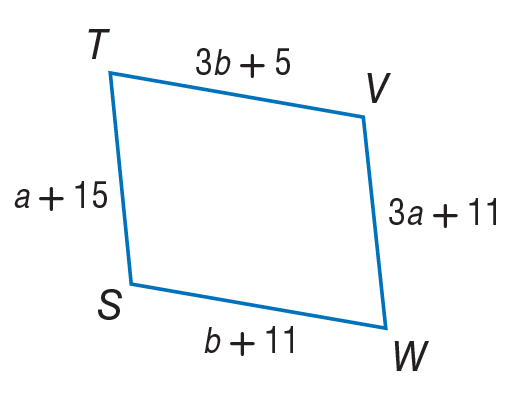Question: Use parallelogram to, find a.
Choices:
A. 1
B. 2
C. 3
D. 4
Answer with the letter. Answer: B Question: Use parallelogram to find b.
Choices:
A. 2
B. 3
C. 14
D. 17
Answer with the letter. Answer: B 